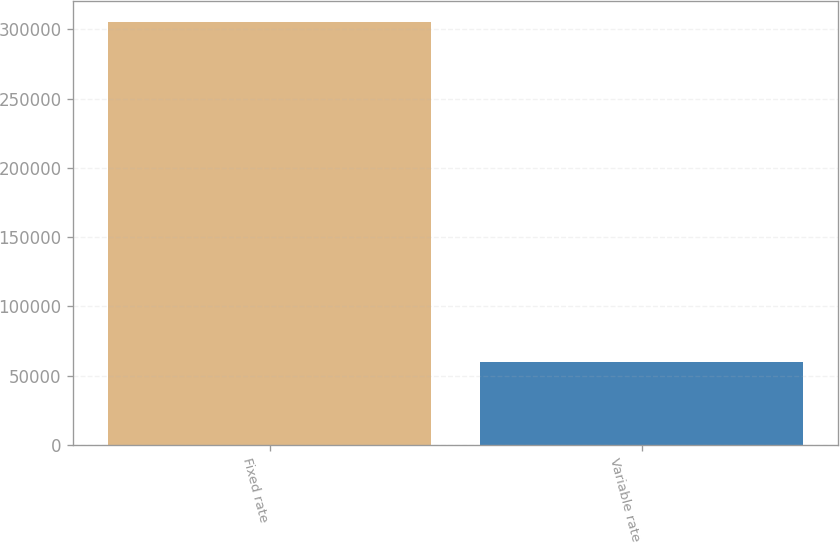Convert chart to OTSL. <chart><loc_0><loc_0><loc_500><loc_500><bar_chart><fcel>Fixed rate<fcel>Variable rate<nl><fcel>305132<fcel>60006<nl></chart> 